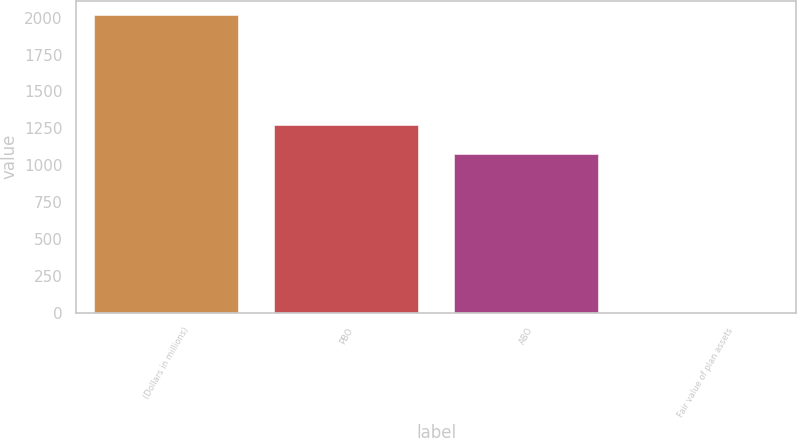Convert chart to OTSL. <chart><loc_0><loc_0><loc_500><loc_500><bar_chart><fcel>(Dollars in millions)<fcel>PBO<fcel>ABO<fcel>Fair value of plan assets<nl><fcel>2015<fcel>1275.4<fcel>1074<fcel>1<nl></chart> 